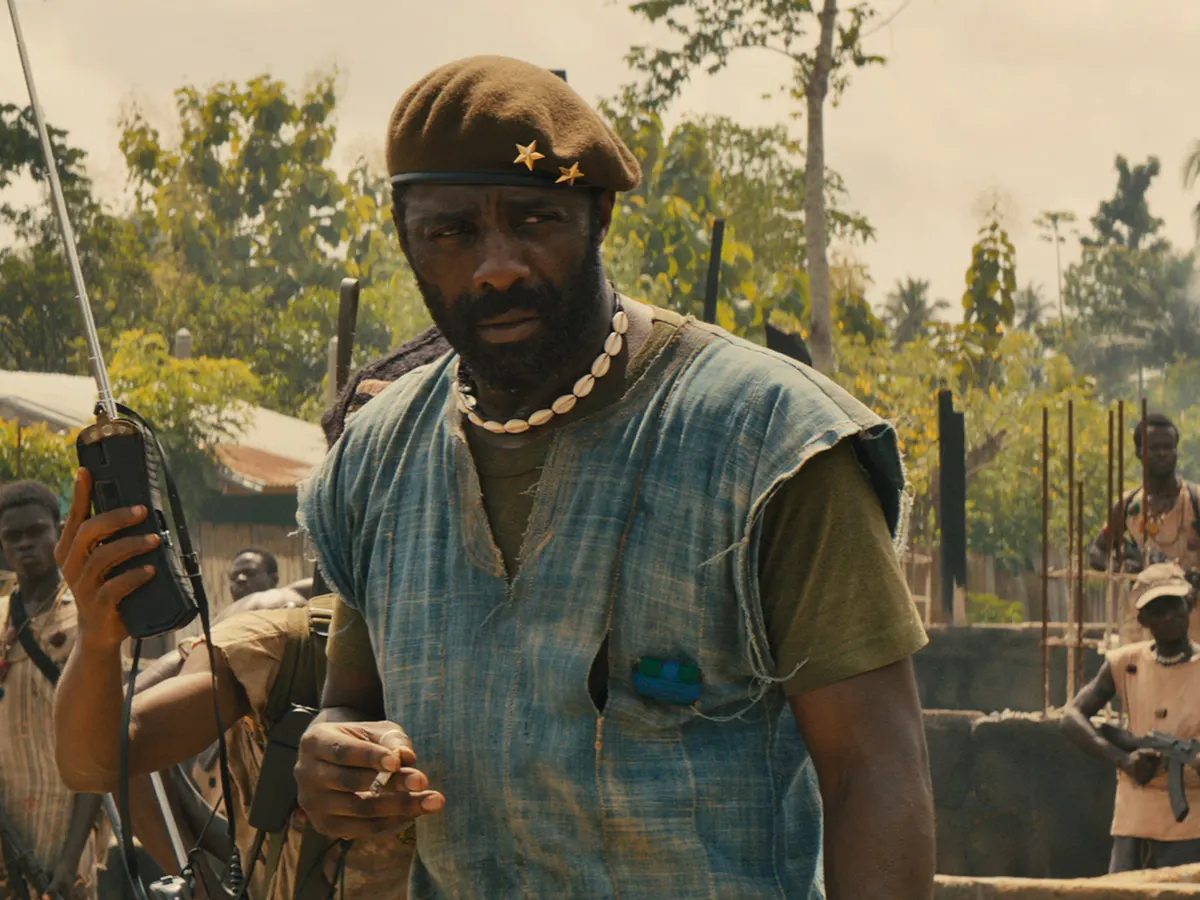What is the context of this scene and the significance of the village setting? The scene depicted in the image is a snapshot from the movie 'Beasts of No Nation', wherein Idris Elba plays the role of Commandant, a militant leader. The village setting underscores the grim reality of a war-torn region, highlighting the constant struggle for control and survival. This setting amplifies the tension and severity of the situation, showing the impact of conflict on both soldiers and villagers. The dust and simple structures emphasize the rugged and undeveloped state of the area, whilst the scattered green foliage suggests resilience amidst destruction. 